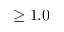<formula> <loc_0><loc_0><loc_500><loc_500>\geq 1 . 0</formula> 